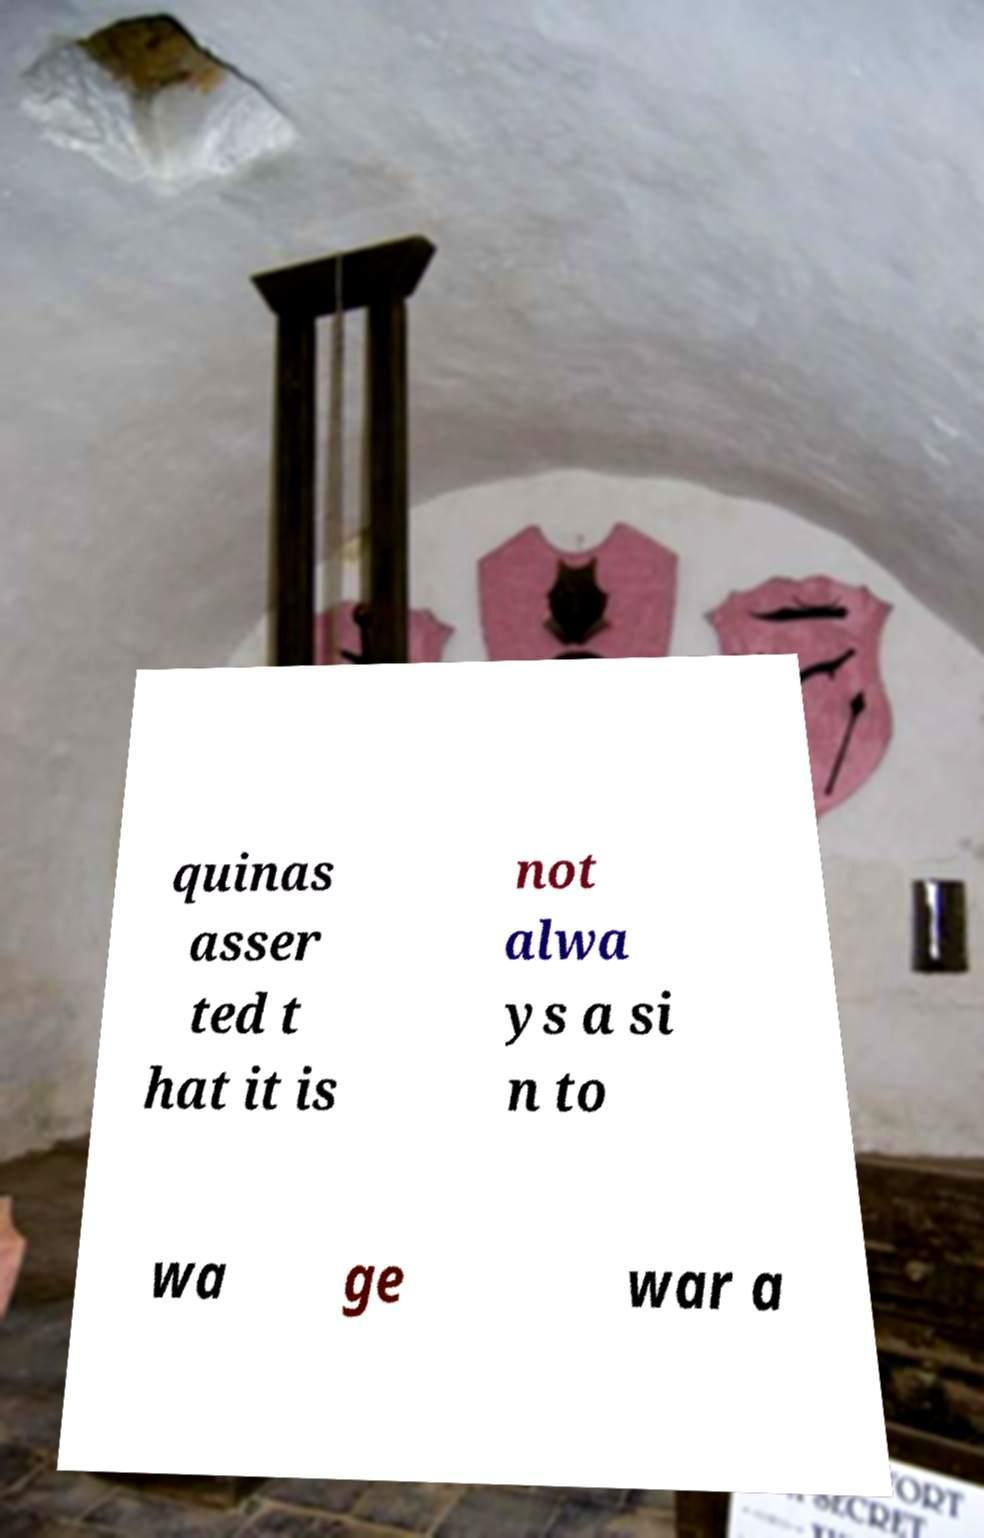Could you assist in decoding the text presented in this image and type it out clearly? quinas asser ted t hat it is not alwa ys a si n to wa ge war a 